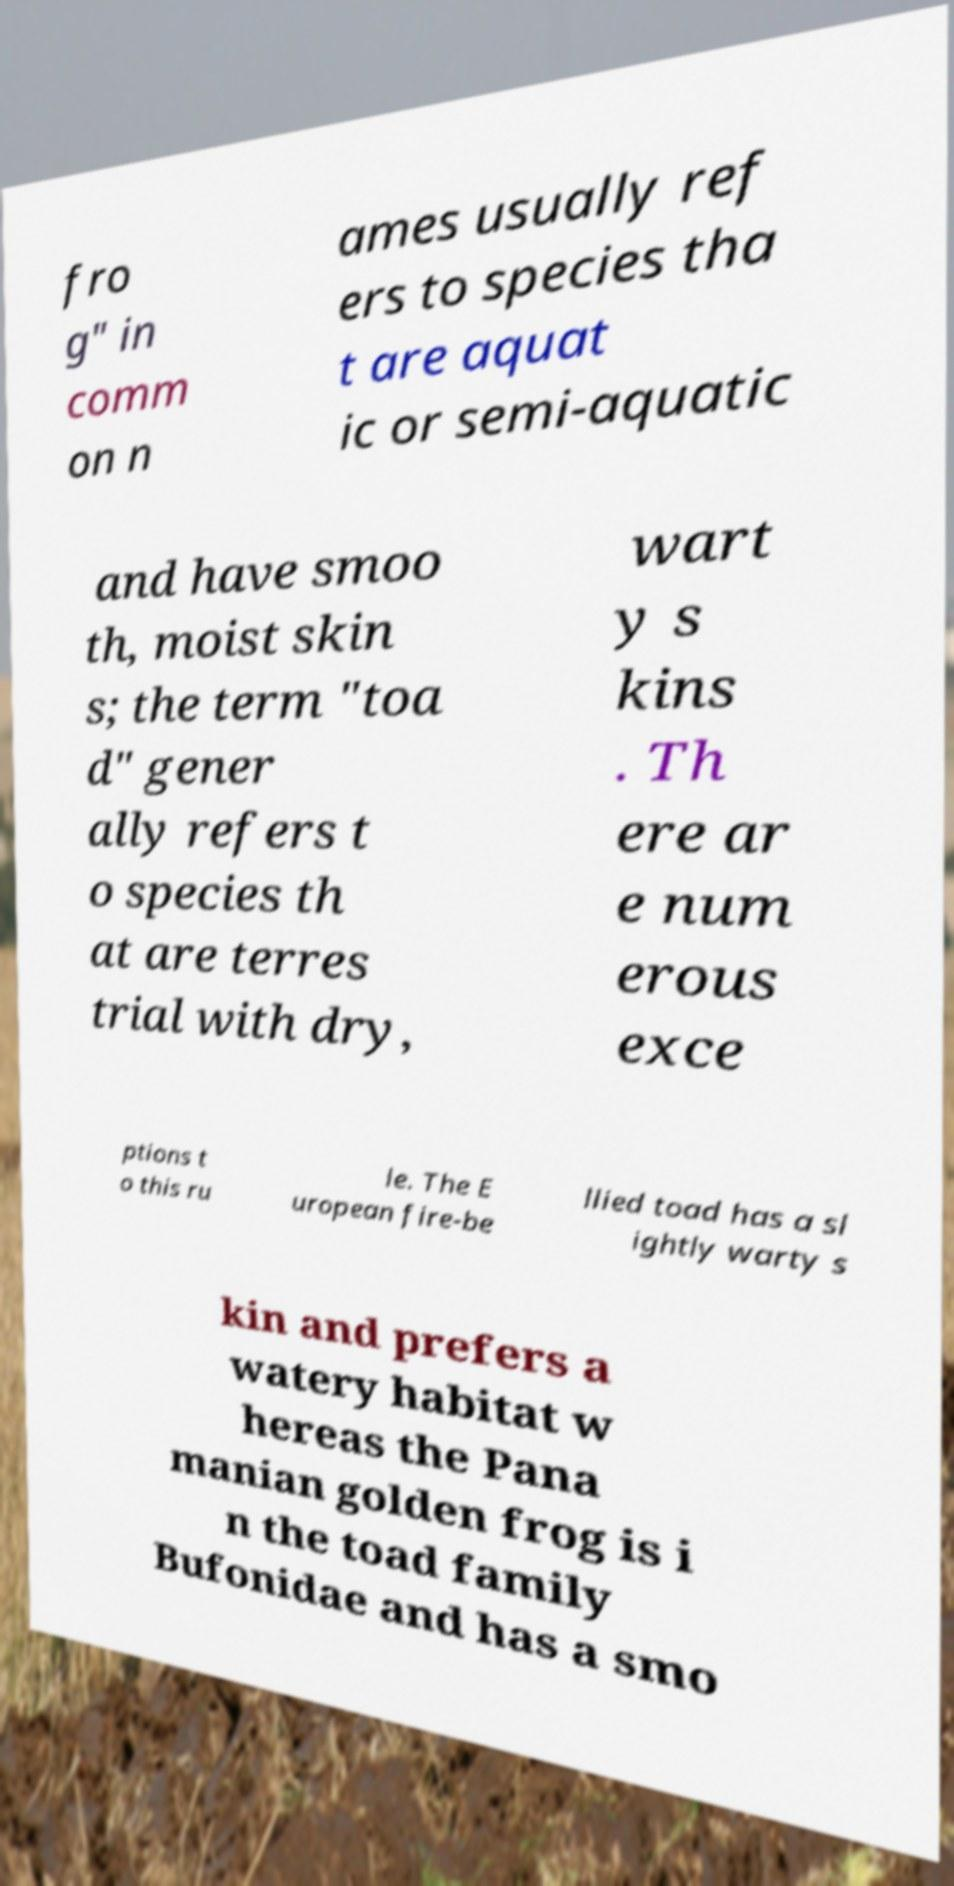Please identify and transcribe the text found in this image. fro g" in comm on n ames usually ref ers to species tha t are aquat ic or semi-aquatic and have smoo th, moist skin s; the term "toa d" gener ally refers t o species th at are terres trial with dry, wart y s kins . Th ere ar e num erous exce ptions t o this ru le. The E uropean fire-be llied toad has a sl ightly warty s kin and prefers a watery habitat w hereas the Pana manian golden frog is i n the toad family Bufonidae and has a smo 